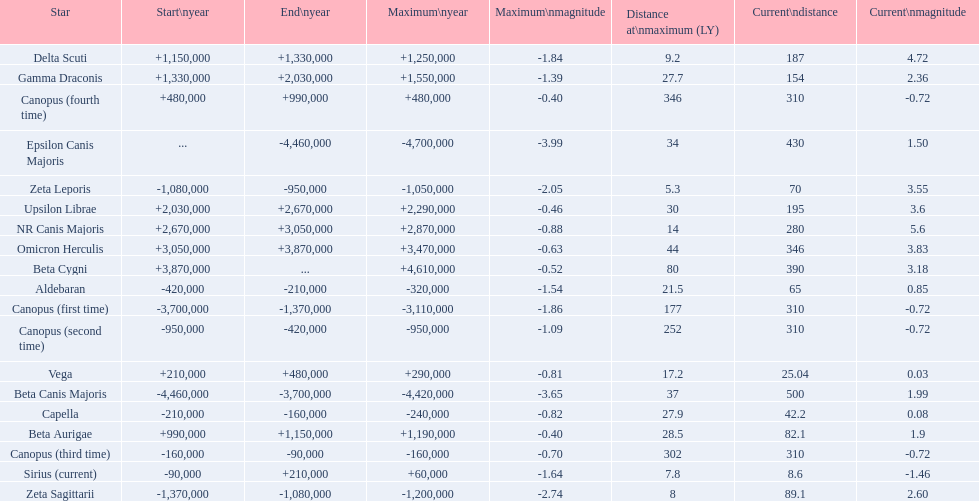What is the difference in the nearest current distance and farthest current distance? 491.4. 